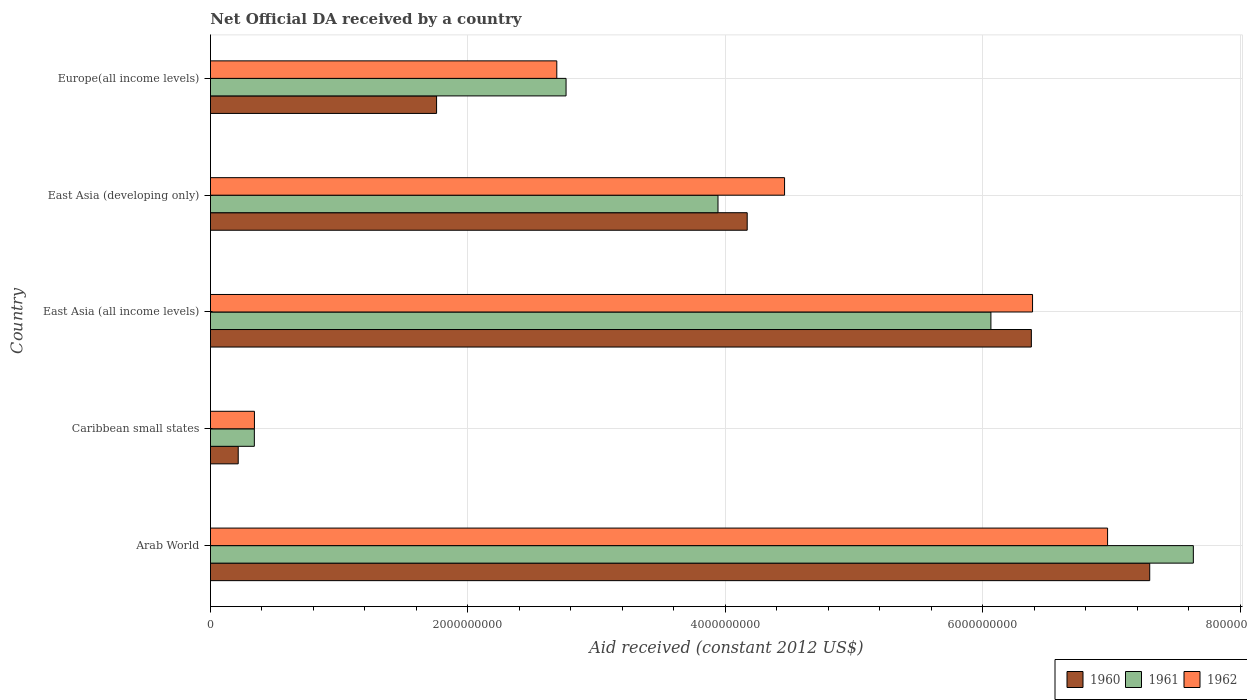Are the number of bars per tick equal to the number of legend labels?
Give a very brief answer. Yes. Are the number of bars on each tick of the Y-axis equal?
Your response must be concise. Yes. How many bars are there on the 2nd tick from the top?
Your answer should be compact. 3. How many bars are there on the 2nd tick from the bottom?
Provide a short and direct response. 3. What is the label of the 1st group of bars from the top?
Provide a succinct answer. Europe(all income levels). What is the net official development assistance aid received in 1960 in East Asia (developing only)?
Offer a very short reply. 4.17e+09. Across all countries, what is the maximum net official development assistance aid received in 1961?
Make the answer very short. 7.64e+09. Across all countries, what is the minimum net official development assistance aid received in 1962?
Your response must be concise. 3.42e+08. In which country was the net official development assistance aid received in 1960 maximum?
Your answer should be very brief. Arab World. In which country was the net official development assistance aid received in 1961 minimum?
Offer a terse response. Caribbean small states. What is the total net official development assistance aid received in 1961 in the graph?
Your answer should be very brief. 2.07e+1. What is the difference between the net official development assistance aid received in 1961 in Arab World and that in Europe(all income levels)?
Keep it short and to the point. 4.87e+09. What is the difference between the net official development assistance aid received in 1962 in Caribbean small states and the net official development assistance aid received in 1960 in East Asia (developing only)?
Provide a succinct answer. -3.83e+09. What is the average net official development assistance aid received in 1960 per country?
Give a very brief answer. 3.96e+09. What is the difference between the net official development assistance aid received in 1960 and net official development assistance aid received in 1961 in East Asia (all income levels)?
Keep it short and to the point. 3.14e+08. In how many countries, is the net official development assistance aid received in 1960 greater than 2800000000 US$?
Your answer should be very brief. 3. What is the ratio of the net official development assistance aid received in 1962 in East Asia (all income levels) to that in Europe(all income levels)?
Keep it short and to the point. 2.37. Is the net official development assistance aid received in 1960 in Arab World less than that in Europe(all income levels)?
Your answer should be very brief. No. What is the difference between the highest and the second highest net official development assistance aid received in 1962?
Your answer should be compact. 5.83e+08. What is the difference between the highest and the lowest net official development assistance aid received in 1960?
Your answer should be very brief. 7.08e+09. In how many countries, is the net official development assistance aid received in 1960 greater than the average net official development assistance aid received in 1960 taken over all countries?
Your answer should be very brief. 3. What does the 1st bar from the top in East Asia (all income levels) represents?
Offer a very short reply. 1962. What does the 2nd bar from the bottom in Caribbean small states represents?
Provide a succinct answer. 1961. Is it the case that in every country, the sum of the net official development assistance aid received in 1962 and net official development assistance aid received in 1960 is greater than the net official development assistance aid received in 1961?
Keep it short and to the point. Yes. What is the difference between two consecutive major ticks on the X-axis?
Your answer should be very brief. 2.00e+09. Does the graph contain any zero values?
Offer a very short reply. No. What is the title of the graph?
Keep it short and to the point. Net Official DA received by a country. What is the label or title of the X-axis?
Make the answer very short. Aid received (constant 2012 US$). What is the label or title of the Y-axis?
Your answer should be compact. Country. What is the Aid received (constant 2012 US$) in 1960 in Arab World?
Provide a succinct answer. 7.30e+09. What is the Aid received (constant 2012 US$) in 1961 in Arab World?
Offer a terse response. 7.64e+09. What is the Aid received (constant 2012 US$) of 1962 in Arab World?
Offer a very short reply. 6.97e+09. What is the Aid received (constant 2012 US$) in 1960 in Caribbean small states?
Your response must be concise. 2.15e+08. What is the Aid received (constant 2012 US$) of 1961 in Caribbean small states?
Offer a very short reply. 3.41e+08. What is the Aid received (constant 2012 US$) of 1962 in Caribbean small states?
Ensure brevity in your answer.  3.42e+08. What is the Aid received (constant 2012 US$) in 1960 in East Asia (all income levels)?
Make the answer very short. 6.38e+09. What is the Aid received (constant 2012 US$) in 1961 in East Asia (all income levels)?
Keep it short and to the point. 6.06e+09. What is the Aid received (constant 2012 US$) in 1962 in East Asia (all income levels)?
Provide a succinct answer. 6.39e+09. What is the Aid received (constant 2012 US$) in 1960 in East Asia (developing only)?
Provide a succinct answer. 4.17e+09. What is the Aid received (constant 2012 US$) of 1961 in East Asia (developing only)?
Provide a succinct answer. 3.94e+09. What is the Aid received (constant 2012 US$) of 1962 in East Asia (developing only)?
Your response must be concise. 4.46e+09. What is the Aid received (constant 2012 US$) of 1960 in Europe(all income levels)?
Offer a terse response. 1.76e+09. What is the Aid received (constant 2012 US$) of 1961 in Europe(all income levels)?
Ensure brevity in your answer.  2.76e+09. What is the Aid received (constant 2012 US$) in 1962 in Europe(all income levels)?
Your response must be concise. 2.69e+09. Across all countries, what is the maximum Aid received (constant 2012 US$) in 1960?
Give a very brief answer. 7.30e+09. Across all countries, what is the maximum Aid received (constant 2012 US$) of 1961?
Your response must be concise. 7.64e+09. Across all countries, what is the maximum Aid received (constant 2012 US$) in 1962?
Provide a short and direct response. 6.97e+09. Across all countries, what is the minimum Aid received (constant 2012 US$) in 1960?
Offer a very short reply. 2.15e+08. Across all countries, what is the minimum Aid received (constant 2012 US$) in 1961?
Your answer should be very brief. 3.41e+08. Across all countries, what is the minimum Aid received (constant 2012 US$) of 1962?
Make the answer very short. 3.42e+08. What is the total Aid received (constant 2012 US$) in 1960 in the graph?
Keep it short and to the point. 1.98e+1. What is the total Aid received (constant 2012 US$) of 1961 in the graph?
Give a very brief answer. 2.07e+1. What is the total Aid received (constant 2012 US$) in 1962 in the graph?
Keep it short and to the point. 2.08e+1. What is the difference between the Aid received (constant 2012 US$) of 1960 in Arab World and that in Caribbean small states?
Ensure brevity in your answer.  7.08e+09. What is the difference between the Aid received (constant 2012 US$) of 1961 in Arab World and that in Caribbean small states?
Keep it short and to the point. 7.29e+09. What is the difference between the Aid received (constant 2012 US$) of 1962 in Arab World and that in Caribbean small states?
Your response must be concise. 6.63e+09. What is the difference between the Aid received (constant 2012 US$) of 1960 in Arab World and that in East Asia (all income levels)?
Ensure brevity in your answer.  9.19e+08. What is the difference between the Aid received (constant 2012 US$) in 1961 in Arab World and that in East Asia (all income levels)?
Make the answer very short. 1.57e+09. What is the difference between the Aid received (constant 2012 US$) of 1962 in Arab World and that in East Asia (all income levels)?
Give a very brief answer. 5.83e+08. What is the difference between the Aid received (constant 2012 US$) of 1960 in Arab World and that in East Asia (developing only)?
Provide a succinct answer. 3.13e+09. What is the difference between the Aid received (constant 2012 US$) in 1961 in Arab World and that in East Asia (developing only)?
Your answer should be compact. 3.69e+09. What is the difference between the Aid received (constant 2012 US$) in 1962 in Arab World and that in East Asia (developing only)?
Your answer should be very brief. 2.51e+09. What is the difference between the Aid received (constant 2012 US$) in 1960 in Arab World and that in Europe(all income levels)?
Ensure brevity in your answer.  5.54e+09. What is the difference between the Aid received (constant 2012 US$) of 1961 in Arab World and that in Europe(all income levels)?
Offer a very short reply. 4.87e+09. What is the difference between the Aid received (constant 2012 US$) in 1962 in Arab World and that in Europe(all income levels)?
Your answer should be compact. 4.28e+09. What is the difference between the Aid received (constant 2012 US$) of 1960 in Caribbean small states and that in East Asia (all income levels)?
Give a very brief answer. -6.16e+09. What is the difference between the Aid received (constant 2012 US$) in 1961 in Caribbean small states and that in East Asia (all income levels)?
Offer a very short reply. -5.72e+09. What is the difference between the Aid received (constant 2012 US$) of 1962 in Caribbean small states and that in East Asia (all income levels)?
Your response must be concise. -6.04e+09. What is the difference between the Aid received (constant 2012 US$) of 1960 in Caribbean small states and that in East Asia (developing only)?
Your response must be concise. -3.95e+09. What is the difference between the Aid received (constant 2012 US$) of 1961 in Caribbean small states and that in East Asia (developing only)?
Your answer should be very brief. -3.60e+09. What is the difference between the Aid received (constant 2012 US$) of 1962 in Caribbean small states and that in East Asia (developing only)?
Make the answer very short. -4.12e+09. What is the difference between the Aid received (constant 2012 US$) of 1960 in Caribbean small states and that in Europe(all income levels)?
Your answer should be compact. -1.54e+09. What is the difference between the Aid received (constant 2012 US$) in 1961 in Caribbean small states and that in Europe(all income levels)?
Provide a short and direct response. -2.42e+09. What is the difference between the Aid received (constant 2012 US$) in 1962 in Caribbean small states and that in Europe(all income levels)?
Ensure brevity in your answer.  -2.35e+09. What is the difference between the Aid received (constant 2012 US$) in 1960 in East Asia (all income levels) and that in East Asia (developing only)?
Provide a short and direct response. 2.21e+09. What is the difference between the Aid received (constant 2012 US$) in 1961 in East Asia (all income levels) and that in East Asia (developing only)?
Make the answer very short. 2.12e+09. What is the difference between the Aid received (constant 2012 US$) of 1962 in East Asia (all income levels) and that in East Asia (developing only)?
Offer a terse response. 1.93e+09. What is the difference between the Aid received (constant 2012 US$) of 1960 in East Asia (all income levels) and that in Europe(all income levels)?
Offer a very short reply. 4.62e+09. What is the difference between the Aid received (constant 2012 US$) in 1961 in East Asia (all income levels) and that in Europe(all income levels)?
Provide a short and direct response. 3.30e+09. What is the difference between the Aid received (constant 2012 US$) in 1962 in East Asia (all income levels) and that in Europe(all income levels)?
Keep it short and to the point. 3.70e+09. What is the difference between the Aid received (constant 2012 US$) in 1960 in East Asia (developing only) and that in Europe(all income levels)?
Give a very brief answer. 2.41e+09. What is the difference between the Aid received (constant 2012 US$) in 1961 in East Asia (developing only) and that in Europe(all income levels)?
Your answer should be compact. 1.18e+09. What is the difference between the Aid received (constant 2012 US$) of 1962 in East Asia (developing only) and that in Europe(all income levels)?
Give a very brief answer. 1.77e+09. What is the difference between the Aid received (constant 2012 US$) of 1960 in Arab World and the Aid received (constant 2012 US$) of 1961 in Caribbean small states?
Ensure brevity in your answer.  6.96e+09. What is the difference between the Aid received (constant 2012 US$) of 1960 in Arab World and the Aid received (constant 2012 US$) of 1962 in Caribbean small states?
Keep it short and to the point. 6.95e+09. What is the difference between the Aid received (constant 2012 US$) of 1961 in Arab World and the Aid received (constant 2012 US$) of 1962 in Caribbean small states?
Your answer should be very brief. 7.29e+09. What is the difference between the Aid received (constant 2012 US$) in 1960 in Arab World and the Aid received (constant 2012 US$) in 1961 in East Asia (all income levels)?
Offer a terse response. 1.23e+09. What is the difference between the Aid received (constant 2012 US$) of 1960 in Arab World and the Aid received (constant 2012 US$) of 1962 in East Asia (all income levels)?
Offer a terse response. 9.10e+08. What is the difference between the Aid received (constant 2012 US$) in 1961 in Arab World and the Aid received (constant 2012 US$) in 1962 in East Asia (all income levels)?
Give a very brief answer. 1.25e+09. What is the difference between the Aid received (constant 2012 US$) in 1960 in Arab World and the Aid received (constant 2012 US$) in 1961 in East Asia (developing only)?
Offer a very short reply. 3.35e+09. What is the difference between the Aid received (constant 2012 US$) in 1960 in Arab World and the Aid received (constant 2012 US$) in 1962 in East Asia (developing only)?
Make the answer very short. 2.84e+09. What is the difference between the Aid received (constant 2012 US$) in 1961 in Arab World and the Aid received (constant 2012 US$) in 1962 in East Asia (developing only)?
Ensure brevity in your answer.  3.18e+09. What is the difference between the Aid received (constant 2012 US$) of 1960 in Arab World and the Aid received (constant 2012 US$) of 1961 in Europe(all income levels)?
Your answer should be very brief. 4.53e+09. What is the difference between the Aid received (constant 2012 US$) of 1960 in Arab World and the Aid received (constant 2012 US$) of 1962 in Europe(all income levels)?
Give a very brief answer. 4.61e+09. What is the difference between the Aid received (constant 2012 US$) of 1961 in Arab World and the Aid received (constant 2012 US$) of 1962 in Europe(all income levels)?
Provide a short and direct response. 4.94e+09. What is the difference between the Aid received (constant 2012 US$) of 1960 in Caribbean small states and the Aid received (constant 2012 US$) of 1961 in East Asia (all income levels)?
Make the answer very short. -5.85e+09. What is the difference between the Aid received (constant 2012 US$) of 1960 in Caribbean small states and the Aid received (constant 2012 US$) of 1962 in East Asia (all income levels)?
Give a very brief answer. -6.17e+09. What is the difference between the Aid received (constant 2012 US$) of 1961 in Caribbean small states and the Aid received (constant 2012 US$) of 1962 in East Asia (all income levels)?
Make the answer very short. -6.05e+09. What is the difference between the Aid received (constant 2012 US$) of 1960 in Caribbean small states and the Aid received (constant 2012 US$) of 1961 in East Asia (developing only)?
Your answer should be compact. -3.73e+09. What is the difference between the Aid received (constant 2012 US$) in 1960 in Caribbean small states and the Aid received (constant 2012 US$) in 1962 in East Asia (developing only)?
Offer a very short reply. -4.24e+09. What is the difference between the Aid received (constant 2012 US$) in 1961 in Caribbean small states and the Aid received (constant 2012 US$) in 1962 in East Asia (developing only)?
Your answer should be compact. -4.12e+09. What is the difference between the Aid received (constant 2012 US$) in 1960 in Caribbean small states and the Aid received (constant 2012 US$) in 1961 in Europe(all income levels)?
Your answer should be compact. -2.55e+09. What is the difference between the Aid received (constant 2012 US$) in 1960 in Caribbean small states and the Aid received (constant 2012 US$) in 1962 in Europe(all income levels)?
Your answer should be very brief. -2.47e+09. What is the difference between the Aid received (constant 2012 US$) of 1961 in Caribbean small states and the Aid received (constant 2012 US$) of 1962 in Europe(all income levels)?
Your answer should be very brief. -2.35e+09. What is the difference between the Aid received (constant 2012 US$) in 1960 in East Asia (all income levels) and the Aid received (constant 2012 US$) in 1961 in East Asia (developing only)?
Provide a short and direct response. 2.43e+09. What is the difference between the Aid received (constant 2012 US$) of 1960 in East Asia (all income levels) and the Aid received (constant 2012 US$) of 1962 in East Asia (developing only)?
Keep it short and to the point. 1.92e+09. What is the difference between the Aid received (constant 2012 US$) in 1961 in East Asia (all income levels) and the Aid received (constant 2012 US$) in 1962 in East Asia (developing only)?
Keep it short and to the point. 1.60e+09. What is the difference between the Aid received (constant 2012 US$) of 1960 in East Asia (all income levels) and the Aid received (constant 2012 US$) of 1961 in Europe(all income levels)?
Provide a short and direct response. 3.61e+09. What is the difference between the Aid received (constant 2012 US$) of 1960 in East Asia (all income levels) and the Aid received (constant 2012 US$) of 1962 in Europe(all income levels)?
Your answer should be compact. 3.69e+09. What is the difference between the Aid received (constant 2012 US$) of 1961 in East Asia (all income levels) and the Aid received (constant 2012 US$) of 1962 in Europe(all income levels)?
Offer a very short reply. 3.37e+09. What is the difference between the Aid received (constant 2012 US$) of 1960 in East Asia (developing only) and the Aid received (constant 2012 US$) of 1961 in Europe(all income levels)?
Offer a terse response. 1.41e+09. What is the difference between the Aid received (constant 2012 US$) of 1960 in East Asia (developing only) and the Aid received (constant 2012 US$) of 1962 in Europe(all income levels)?
Offer a very short reply. 1.48e+09. What is the difference between the Aid received (constant 2012 US$) in 1961 in East Asia (developing only) and the Aid received (constant 2012 US$) in 1962 in Europe(all income levels)?
Keep it short and to the point. 1.25e+09. What is the average Aid received (constant 2012 US$) in 1960 per country?
Give a very brief answer. 3.96e+09. What is the average Aid received (constant 2012 US$) in 1961 per country?
Offer a very short reply. 4.15e+09. What is the average Aid received (constant 2012 US$) of 1962 per country?
Make the answer very short. 4.17e+09. What is the difference between the Aid received (constant 2012 US$) of 1960 and Aid received (constant 2012 US$) of 1961 in Arab World?
Your response must be concise. -3.39e+08. What is the difference between the Aid received (constant 2012 US$) in 1960 and Aid received (constant 2012 US$) in 1962 in Arab World?
Provide a succinct answer. 3.27e+08. What is the difference between the Aid received (constant 2012 US$) of 1961 and Aid received (constant 2012 US$) of 1962 in Arab World?
Offer a very short reply. 6.66e+08. What is the difference between the Aid received (constant 2012 US$) in 1960 and Aid received (constant 2012 US$) in 1961 in Caribbean small states?
Your answer should be compact. -1.25e+08. What is the difference between the Aid received (constant 2012 US$) in 1960 and Aid received (constant 2012 US$) in 1962 in Caribbean small states?
Your answer should be very brief. -1.26e+08. What is the difference between the Aid received (constant 2012 US$) of 1961 and Aid received (constant 2012 US$) of 1962 in Caribbean small states?
Ensure brevity in your answer.  -7.40e+05. What is the difference between the Aid received (constant 2012 US$) in 1960 and Aid received (constant 2012 US$) in 1961 in East Asia (all income levels)?
Keep it short and to the point. 3.14e+08. What is the difference between the Aid received (constant 2012 US$) of 1960 and Aid received (constant 2012 US$) of 1962 in East Asia (all income levels)?
Provide a succinct answer. -9.20e+06. What is the difference between the Aid received (constant 2012 US$) of 1961 and Aid received (constant 2012 US$) of 1962 in East Asia (all income levels)?
Your answer should be compact. -3.24e+08. What is the difference between the Aid received (constant 2012 US$) in 1960 and Aid received (constant 2012 US$) in 1961 in East Asia (developing only)?
Offer a very short reply. 2.27e+08. What is the difference between the Aid received (constant 2012 US$) of 1960 and Aid received (constant 2012 US$) of 1962 in East Asia (developing only)?
Make the answer very short. -2.90e+08. What is the difference between the Aid received (constant 2012 US$) in 1961 and Aid received (constant 2012 US$) in 1962 in East Asia (developing only)?
Keep it short and to the point. -5.17e+08. What is the difference between the Aid received (constant 2012 US$) in 1960 and Aid received (constant 2012 US$) in 1961 in Europe(all income levels)?
Your answer should be compact. -1.01e+09. What is the difference between the Aid received (constant 2012 US$) in 1960 and Aid received (constant 2012 US$) in 1962 in Europe(all income levels)?
Your answer should be very brief. -9.34e+08. What is the difference between the Aid received (constant 2012 US$) in 1961 and Aid received (constant 2012 US$) in 1962 in Europe(all income levels)?
Keep it short and to the point. 7.20e+07. What is the ratio of the Aid received (constant 2012 US$) in 1960 in Arab World to that in Caribbean small states?
Provide a succinct answer. 33.86. What is the ratio of the Aid received (constant 2012 US$) of 1961 in Arab World to that in Caribbean small states?
Ensure brevity in your answer.  22.4. What is the ratio of the Aid received (constant 2012 US$) of 1962 in Arab World to that in Caribbean small states?
Provide a short and direct response. 20.4. What is the ratio of the Aid received (constant 2012 US$) in 1960 in Arab World to that in East Asia (all income levels)?
Make the answer very short. 1.14. What is the ratio of the Aid received (constant 2012 US$) of 1961 in Arab World to that in East Asia (all income levels)?
Your answer should be compact. 1.26. What is the ratio of the Aid received (constant 2012 US$) in 1962 in Arab World to that in East Asia (all income levels)?
Make the answer very short. 1.09. What is the ratio of the Aid received (constant 2012 US$) of 1960 in Arab World to that in East Asia (developing only)?
Give a very brief answer. 1.75. What is the ratio of the Aid received (constant 2012 US$) in 1961 in Arab World to that in East Asia (developing only)?
Your answer should be very brief. 1.94. What is the ratio of the Aid received (constant 2012 US$) in 1962 in Arab World to that in East Asia (developing only)?
Ensure brevity in your answer.  1.56. What is the ratio of the Aid received (constant 2012 US$) of 1960 in Arab World to that in Europe(all income levels)?
Ensure brevity in your answer.  4.15. What is the ratio of the Aid received (constant 2012 US$) of 1961 in Arab World to that in Europe(all income levels)?
Make the answer very short. 2.76. What is the ratio of the Aid received (constant 2012 US$) in 1962 in Arab World to that in Europe(all income levels)?
Ensure brevity in your answer.  2.59. What is the ratio of the Aid received (constant 2012 US$) in 1960 in Caribbean small states to that in East Asia (all income levels)?
Your response must be concise. 0.03. What is the ratio of the Aid received (constant 2012 US$) of 1961 in Caribbean small states to that in East Asia (all income levels)?
Ensure brevity in your answer.  0.06. What is the ratio of the Aid received (constant 2012 US$) of 1962 in Caribbean small states to that in East Asia (all income levels)?
Your answer should be very brief. 0.05. What is the ratio of the Aid received (constant 2012 US$) of 1960 in Caribbean small states to that in East Asia (developing only)?
Your answer should be very brief. 0.05. What is the ratio of the Aid received (constant 2012 US$) of 1961 in Caribbean small states to that in East Asia (developing only)?
Give a very brief answer. 0.09. What is the ratio of the Aid received (constant 2012 US$) in 1962 in Caribbean small states to that in East Asia (developing only)?
Your response must be concise. 0.08. What is the ratio of the Aid received (constant 2012 US$) of 1960 in Caribbean small states to that in Europe(all income levels)?
Provide a short and direct response. 0.12. What is the ratio of the Aid received (constant 2012 US$) of 1961 in Caribbean small states to that in Europe(all income levels)?
Provide a short and direct response. 0.12. What is the ratio of the Aid received (constant 2012 US$) of 1962 in Caribbean small states to that in Europe(all income levels)?
Your answer should be compact. 0.13. What is the ratio of the Aid received (constant 2012 US$) of 1960 in East Asia (all income levels) to that in East Asia (developing only)?
Your response must be concise. 1.53. What is the ratio of the Aid received (constant 2012 US$) of 1961 in East Asia (all income levels) to that in East Asia (developing only)?
Give a very brief answer. 1.54. What is the ratio of the Aid received (constant 2012 US$) of 1962 in East Asia (all income levels) to that in East Asia (developing only)?
Provide a succinct answer. 1.43. What is the ratio of the Aid received (constant 2012 US$) of 1960 in East Asia (all income levels) to that in Europe(all income levels)?
Provide a short and direct response. 3.63. What is the ratio of the Aid received (constant 2012 US$) in 1961 in East Asia (all income levels) to that in Europe(all income levels)?
Your answer should be very brief. 2.19. What is the ratio of the Aid received (constant 2012 US$) in 1962 in East Asia (all income levels) to that in Europe(all income levels)?
Offer a terse response. 2.37. What is the ratio of the Aid received (constant 2012 US$) in 1960 in East Asia (developing only) to that in Europe(all income levels)?
Your response must be concise. 2.37. What is the ratio of the Aid received (constant 2012 US$) of 1961 in East Asia (developing only) to that in Europe(all income levels)?
Provide a succinct answer. 1.43. What is the ratio of the Aid received (constant 2012 US$) of 1962 in East Asia (developing only) to that in Europe(all income levels)?
Keep it short and to the point. 1.66. What is the difference between the highest and the second highest Aid received (constant 2012 US$) of 1960?
Provide a short and direct response. 9.19e+08. What is the difference between the highest and the second highest Aid received (constant 2012 US$) of 1961?
Your answer should be very brief. 1.57e+09. What is the difference between the highest and the second highest Aid received (constant 2012 US$) in 1962?
Make the answer very short. 5.83e+08. What is the difference between the highest and the lowest Aid received (constant 2012 US$) of 1960?
Provide a short and direct response. 7.08e+09. What is the difference between the highest and the lowest Aid received (constant 2012 US$) of 1961?
Ensure brevity in your answer.  7.29e+09. What is the difference between the highest and the lowest Aid received (constant 2012 US$) in 1962?
Offer a very short reply. 6.63e+09. 